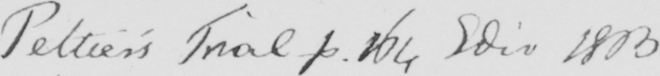Transcribe the text shown in this historical manuscript line. Peltier ' s Trial p . 164 Edit 1803 